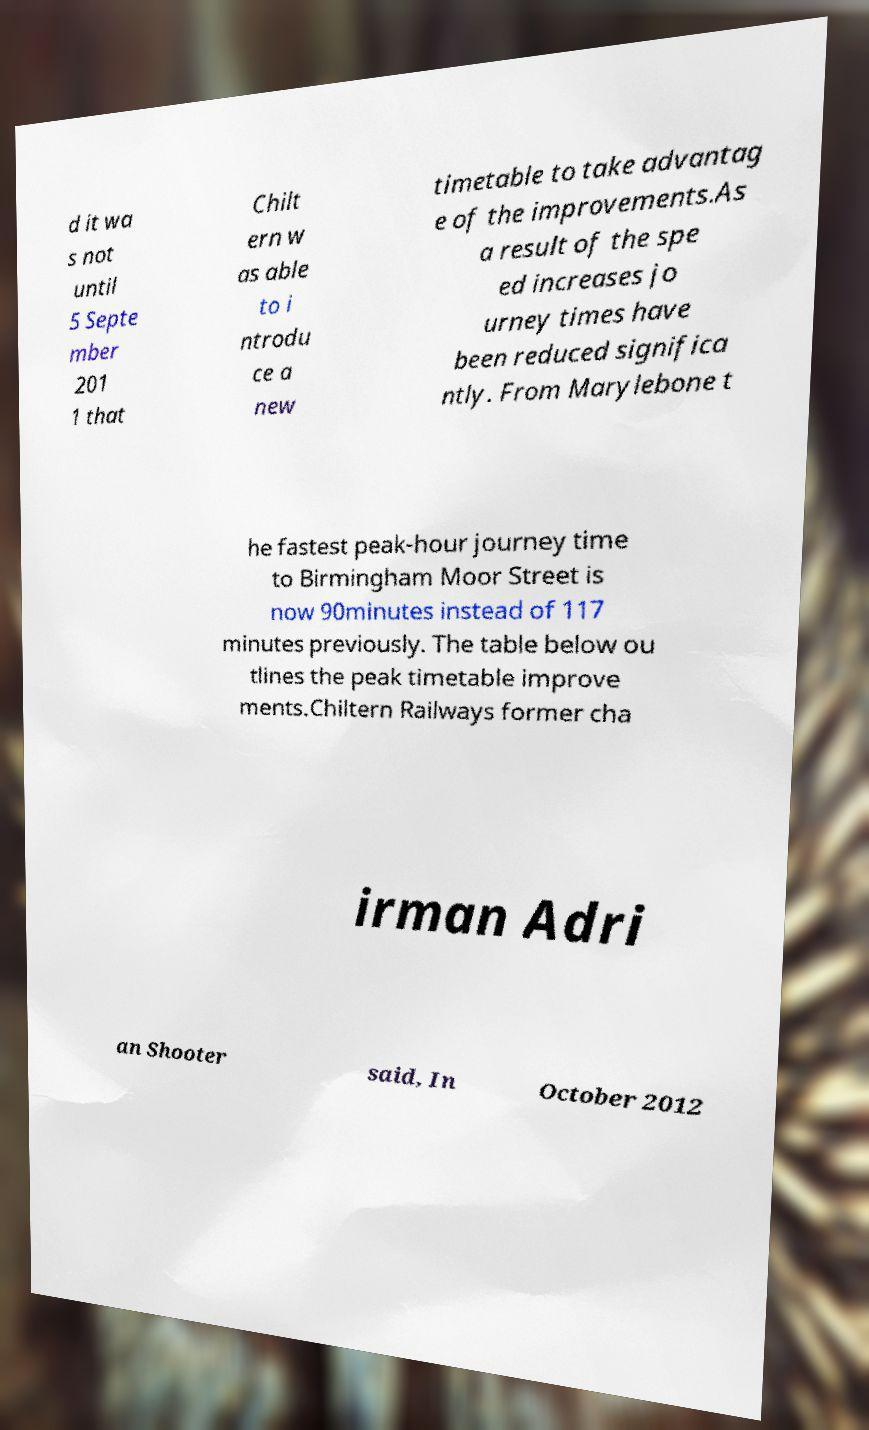Could you assist in decoding the text presented in this image and type it out clearly? d it wa s not until 5 Septe mber 201 1 that Chilt ern w as able to i ntrodu ce a new timetable to take advantag e of the improvements.As a result of the spe ed increases jo urney times have been reduced significa ntly. From Marylebone t he fastest peak-hour journey time to Birmingham Moor Street is now 90minutes instead of 117 minutes previously. The table below ou tlines the peak timetable improve ments.Chiltern Railways former cha irman Adri an Shooter said, In October 2012 